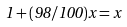<formula> <loc_0><loc_0><loc_500><loc_500>1 + ( 9 8 / 1 0 0 ) x = x</formula> 